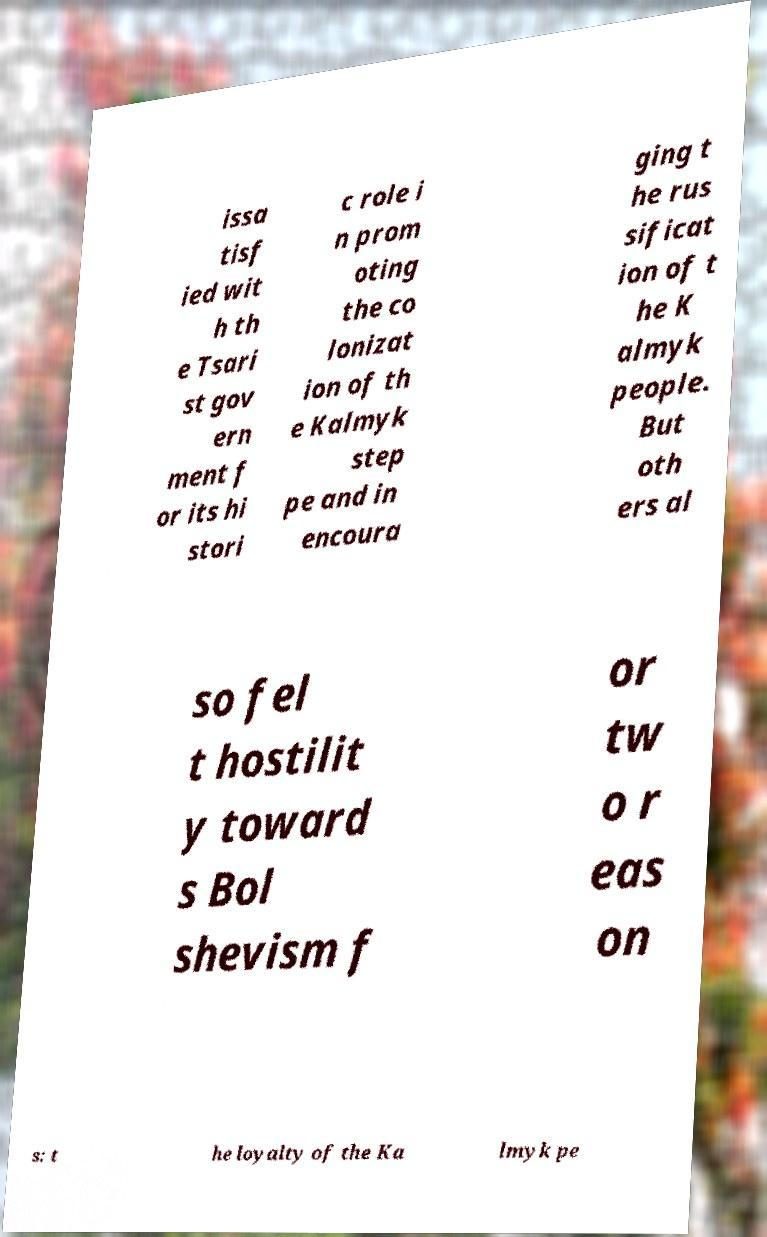Can you read and provide the text displayed in the image?This photo seems to have some interesting text. Can you extract and type it out for me? issa tisf ied wit h th e Tsari st gov ern ment f or its hi stori c role i n prom oting the co lonizat ion of th e Kalmyk step pe and in encoura ging t he rus sificat ion of t he K almyk people. But oth ers al so fel t hostilit y toward s Bol shevism f or tw o r eas on s: t he loyalty of the Ka lmyk pe 